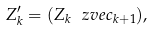Convert formula to latex. <formula><loc_0><loc_0><loc_500><loc_500>Z _ { k } ^ { \prime } = ( Z _ { k } \, \ z v e c _ { k + 1 } ) ,</formula> 